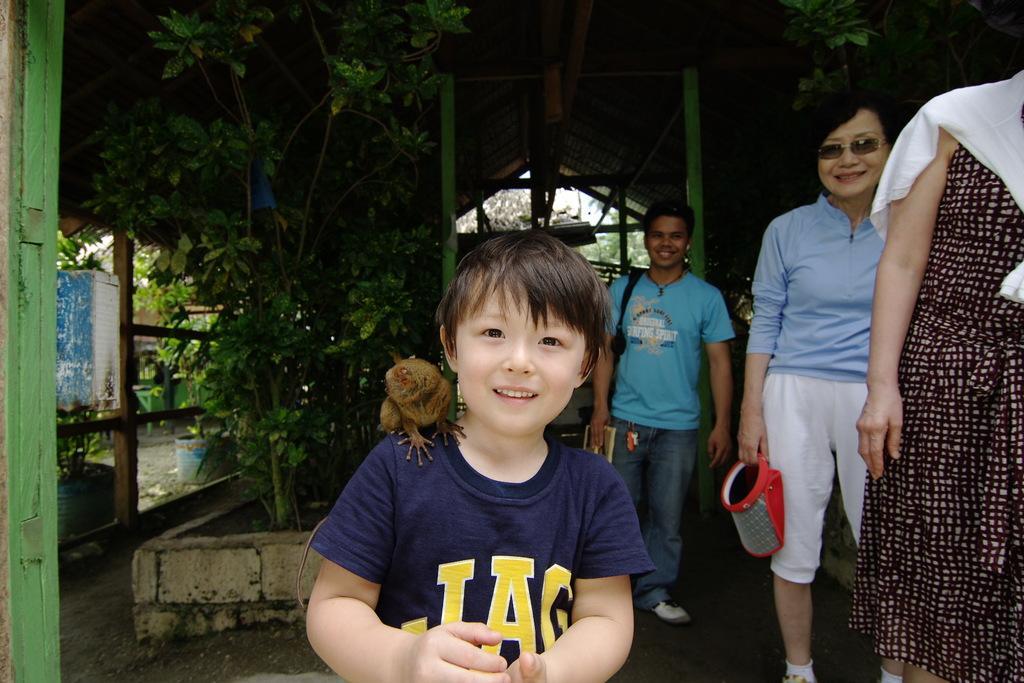How would you summarize this image in a sentence or two? In this picture there is a boy who is wearing t-shirt and he is smiling. On his shoulder I can see some animal. On the right there is a woman who is wearing white scarf and maroon dress and there is another woman who is wearing goggles, t-shirt, short and shoe. She is holding red box. Behind there is a man who is wearing black t-shirt, trouser, and shoe. He is holding a book. In the back I can see the plants, doors and poles. At the top there is a shed. Through the door I can see the trees and sky. 